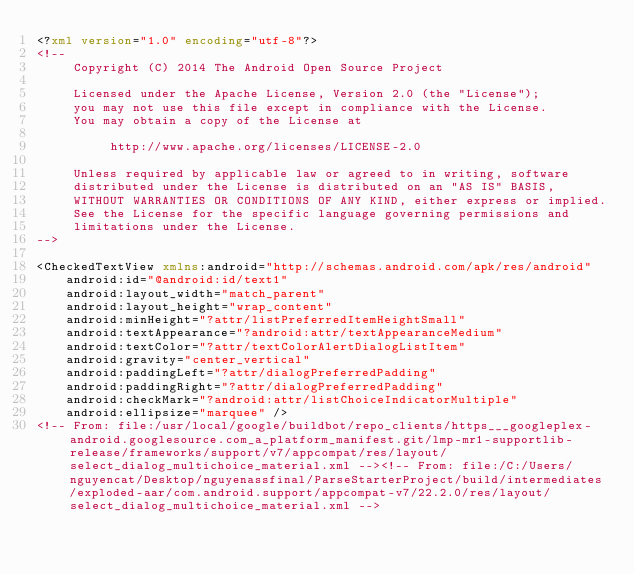<code> <loc_0><loc_0><loc_500><loc_500><_XML_><?xml version="1.0" encoding="utf-8"?>
<!--
     Copyright (C) 2014 The Android Open Source Project

     Licensed under the Apache License, Version 2.0 (the "License");
     you may not use this file except in compliance with the License.
     You may obtain a copy of the License at

          http://www.apache.org/licenses/LICENSE-2.0

     Unless required by applicable law or agreed to in writing, software
     distributed under the License is distributed on an "AS IS" BASIS,
     WITHOUT WARRANTIES OR CONDITIONS OF ANY KIND, either express or implied.
     See the License for the specific language governing permissions and
     limitations under the License.
-->

<CheckedTextView xmlns:android="http://schemas.android.com/apk/res/android"
    android:id="@android:id/text1"
    android:layout_width="match_parent"
    android:layout_height="wrap_content"
    android:minHeight="?attr/listPreferredItemHeightSmall"
    android:textAppearance="?android:attr/textAppearanceMedium"
    android:textColor="?attr/textColorAlertDialogListItem"
    android:gravity="center_vertical"
    android:paddingLeft="?attr/dialogPreferredPadding"
    android:paddingRight="?attr/dialogPreferredPadding"
    android:checkMark="?android:attr/listChoiceIndicatorMultiple"
    android:ellipsize="marquee" />
<!-- From: file:/usr/local/google/buildbot/repo_clients/https___googleplex-android.googlesource.com_a_platform_manifest.git/lmp-mr1-supportlib-release/frameworks/support/v7/appcompat/res/layout/select_dialog_multichoice_material.xml --><!-- From: file:/C:/Users/nguyencat/Desktop/nguyenassfinal/ParseStarterProject/build/intermediates/exploded-aar/com.android.support/appcompat-v7/22.2.0/res/layout/select_dialog_multichoice_material.xml --></code> 